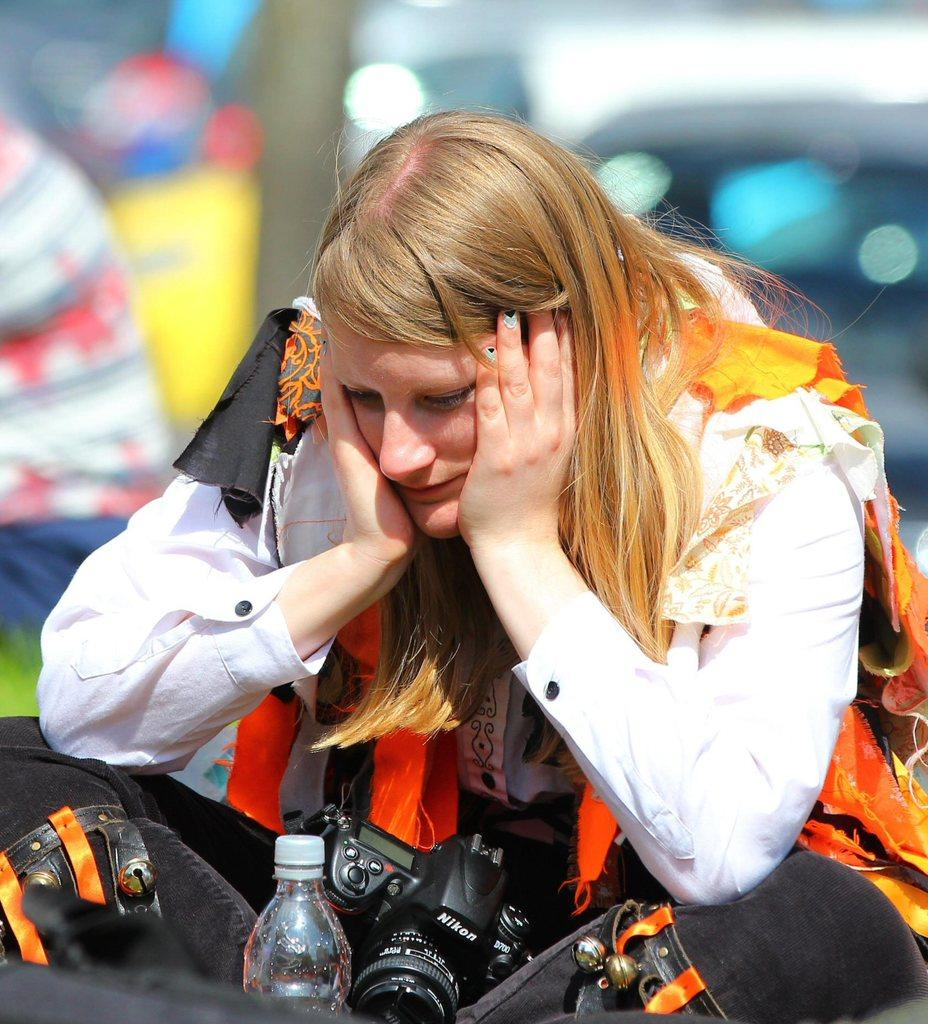Who is the main subject in the image? There is a woman in the image. What is the woman wearing? The woman is wearing a camera. What object is in front of the woman? There is a water bottle in front of the woman. What is the woman doing in the image? The woman is staring at the water bottle. How many clams can be seen in the image? There are no clams present in the image. What is the rate of the hole in the image? There is no hole present in the image. 